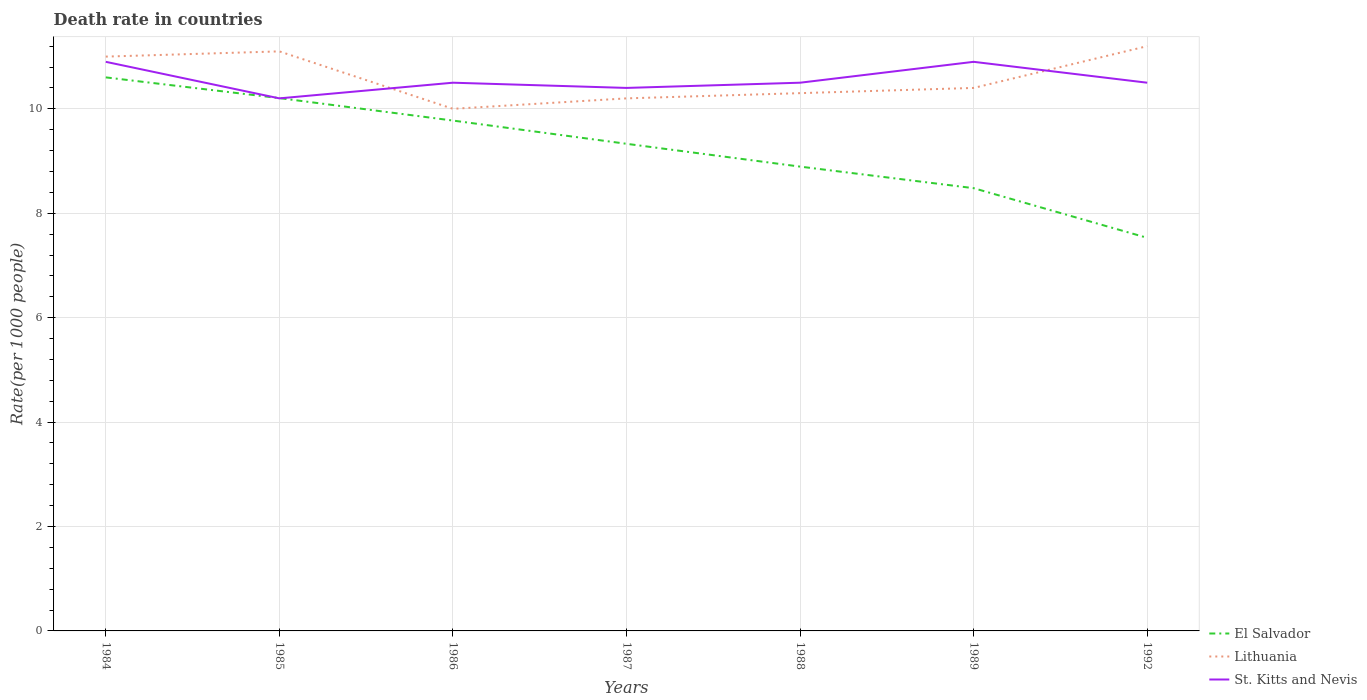Does the line corresponding to St. Kitts and Nevis intersect with the line corresponding to Lithuania?
Offer a very short reply. Yes. Across all years, what is the maximum death rate in Lithuania?
Your response must be concise. 10. What is the total death rate in Lithuania in the graph?
Give a very brief answer. -0.3. What is the difference between the highest and the second highest death rate in Lithuania?
Offer a terse response. 1.2. Is the death rate in El Salvador strictly greater than the death rate in Lithuania over the years?
Your response must be concise. Yes. How many lines are there?
Your response must be concise. 3. What is the difference between two consecutive major ticks on the Y-axis?
Provide a succinct answer. 2. Does the graph contain any zero values?
Make the answer very short. No. How are the legend labels stacked?
Give a very brief answer. Vertical. What is the title of the graph?
Make the answer very short. Death rate in countries. What is the label or title of the X-axis?
Ensure brevity in your answer.  Years. What is the label or title of the Y-axis?
Provide a succinct answer. Rate(per 1000 people). What is the Rate(per 1000 people) in El Salvador in 1984?
Your response must be concise. 10.6. What is the Rate(per 1000 people) in El Salvador in 1985?
Your answer should be very brief. 10.21. What is the Rate(per 1000 people) in Lithuania in 1985?
Ensure brevity in your answer.  11.1. What is the Rate(per 1000 people) of St. Kitts and Nevis in 1985?
Your answer should be compact. 10.2. What is the Rate(per 1000 people) in El Salvador in 1986?
Offer a terse response. 9.78. What is the Rate(per 1000 people) of St. Kitts and Nevis in 1986?
Offer a very short reply. 10.5. What is the Rate(per 1000 people) of El Salvador in 1987?
Ensure brevity in your answer.  9.33. What is the Rate(per 1000 people) in Lithuania in 1987?
Provide a short and direct response. 10.2. What is the Rate(per 1000 people) of St. Kitts and Nevis in 1987?
Your answer should be very brief. 10.4. What is the Rate(per 1000 people) in El Salvador in 1988?
Offer a very short reply. 8.89. What is the Rate(per 1000 people) of Lithuania in 1988?
Give a very brief answer. 10.3. What is the Rate(per 1000 people) in El Salvador in 1989?
Your response must be concise. 8.48. What is the Rate(per 1000 people) in El Salvador in 1992?
Offer a very short reply. 7.53. What is the Rate(per 1000 people) of Lithuania in 1992?
Offer a terse response. 11.2. What is the Rate(per 1000 people) in St. Kitts and Nevis in 1992?
Your answer should be very brief. 10.5. Across all years, what is the maximum Rate(per 1000 people) of El Salvador?
Make the answer very short. 10.6. Across all years, what is the maximum Rate(per 1000 people) in Lithuania?
Your response must be concise. 11.2. Across all years, what is the maximum Rate(per 1000 people) in St. Kitts and Nevis?
Keep it short and to the point. 10.9. Across all years, what is the minimum Rate(per 1000 people) of El Salvador?
Make the answer very short. 7.53. Across all years, what is the minimum Rate(per 1000 people) of St. Kitts and Nevis?
Give a very brief answer. 10.2. What is the total Rate(per 1000 people) in El Salvador in the graph?
Ensure brevity in your answer.  64.81. What is the total Rate(per 1000 people) in Lithuania in the graph?
Your answer should be very brief. 74.2. What is the total Rate(per 1000 people) of St. Kitts and Nevis in the graph?
Provide a short and direct response. 73.9. What is the difference between the Rate(per 1000 people) of El Salvador in 1984 and that in 1985?
Make the answer very short. 0.4. What is the difference between the Rate(per 1000 people) of St. Kitts and Nevis in 1984 and that in 1985?
Offer a very short reply. 0.7. What is the difference between the Rate(per 1000 people) in El Salvador in 1984 and that in 1986?
Provide a short and direct response. 0.83. What is the difference between the Rate(per 1000 people) of St. Kitts and Nevis in 1984 and that in 1986?
Provide a succinct answer. 0.4. What is the difference between the Rate(per 1000 people) of El Salvador in 1984 and that in 1987?
Provide a succinct answer. 1.27. What is the difference between the Rate(per 1000 people) of El Salvador in 1984 and that in 1988?
Your response must be concise. 1.71. What is the difference between the Rate(per 1000 people) of St. Kitts and Nevis in 1984 and that in 1988?
Make the answer very short. 0.4. What is the difference between the Rate(per 1000 people) of El Salvador in 1984 and that in 1989?
Provide a short and direct response. 2.12. What is the difference between the Rate(per 1000 people) of Lithuania in 1984 and that in 1989?
Offer a terse response. 0.6. What is the difference between the Rate(per 1000 people) in St. Kitts and Nevis in 1984 and that in 1989?
Your response must be concise. 0. What is the difference between the Rate(per 1000 people) of El Salvador in 1984 and that in 1992?
Offer a very short reply. 3.07. What is the difference between the Rate(per 1000 people) of St. Kitts and Nevis in 1984 and that in 1992?
Provide a short and direct response. 0.4. What is the difference between the Rate(per 1000 people) in El Salvador in 1985 and that in 1986?
Keep it short and to the point. 0.43. What is the difference between the Rate(per 1000 people) of Lithuania in 1985 and that in 1986?
Your answer should be very brief. 1.1. What is the difference between the Rate(per 1000 people) of El Salvador in 1985 and that in 1987?
Ensure brevity in your answer.  0.88. What is the difference between the Rate(per 1000 people) in St. Kitts and Nevis in 1985 and that in 1987?
Your response must be concise. -0.2. What is the difference between the Rate(per 1000 people) in El Salvador in 1985 and that in 1988?
Your answer should be compact. 1.31. What is the difference between the Rate(per 1000 people) in St. Kitts and Nevis in 1985 and that in 1988?
Ensure brevity in your answer.  -0.3. What is the difference between the Rate(per 1000 people) of El Salvador in 1985 and that in 1989?
Give a very brief answer. 1.73. What is the difference between the Rate(per 1000 people) in Lithuania in 1985 and that in 1989?
Provide a short and direct response. 0.7. What is the difference between the Rate(per 1000 people) in St. Kitts and Nevis in 1985 and that in 1989?
Offer a terse response. -0.7. What is the difference between the Rate(per 1000 people) in El Salvador in 1985 and that in 1992?
Make the answer very short. 2.68. What is the difference between the Rate(per 1000 people) of St. Kitts and Nevis in 1985 and that in 1992?
Offer a terse response. -0.3. What is the difference between the Rate(per 1000 people) in El Salvador in 1986 and that in 1987?
Provide a succinct answer. 0.45. What is the difference between the Rate(per 1000 people) in Lithuania in 1986 and that in 1987?
Keep it short and to the point. -0.2. What is the difference between the Rate(per 1000 people) of El Salvador in 1986 and that in 1988?
Give a very brief answer. 0.88. What is the difference between the Rate(per 1000 people) in El Salvador in 1986 and that in 1989?
Ensure brevity in your answer.  1.29. What is the difference between the Rate(per 1000 people) of St. Kitts and Nevis in 1986 and that in 1989?
Offer a very short reply. -0.4. What is the difference between the Rate(per 1000 people) in El Salvador in 1986 and that in 1992?
Provide a succinct answer. 2.25. What is the difference between the Rate(per 1000 people) in El Salvador in 1987 and that in 1988?
Your response must be concise. 0.44. What is the difference between the Rate(per 1000 people) in Lithuania in 1987 and that in 1988?
Your answer should be compact. -0.1. What is the difference between the Rate(per 1000 people) of St. Kitts and Nevis in 1987 and that in 1988?
Your answer should be compact. -0.1. What is the difference between the Rate(per 1000 people) of El Salvador in 1987 and that in 1989?
Provide a succinct answer. 0.85. What is the difference between the Rate(per 1000 people) in St. Kitts and Nevis in 1987 and that in 1989?
Give a very brief answer. -0.5. What is the difference between the Rate(per 1000 people) in El Salvador in 1987 and that in 1992?
Offer a terse response. 1.8. What is the difference between the Rate(per 1000 people) in Lithuania in 1987 and that in 1992?
Your answer should be very brief. -1. What is the difference between the Rate(per 1000 people) of St. Kitts and Nevis in 1987 and that in 1992?
Ensure brevity in your answer.  -0.1. What is the difference between the Rate(per 1000 people) of El Salvador in 1988 and that in 1989?
Your response must be concise. 0.41. What is the difference between the Rate(per 1000 people) in Lithuania in 1988 and that in 1989?
Provide a short and direct response. -0.1. What is the difference between the Rate(per 1000 people) of El Salvador in 1988 and that in 1992?
Provide a succinct answer. 1.36. What is the difference between the Rate(per 1000 people) in Lithuania in 1988 and that in 1992?
Make the answer very short. -0.9. What is the difference between the Rate(per 1000 people) of El Salvador in 1989 and that in 1992?
Ensure brevity in your answer.  0.95. What is the difference between the Rate(per 1000 people) of St. Kitts and Nevis in 1989 and that in 1992?
Offer a terse response. 0.4. What is the difference between the Rate(per 1000 people) of El Salvador in 1984 and the Rate(per 1000 people) of Lithuania in 1985?
Ensure brevity in your answer.  -0.5. What is the difference between the Rate(per 1000 people) of El Salvador in 1984 and the Rate(per 1000 people) of St. Kitts and Nevis in 1985?
Provide a succinct answer. 0.4. What is the difference between the Rate(per 1000 people) in Lithuania in 1984 and the Rate(per 1000 people) in St. Kitts and Nevis in 1985?
Keep it short and to the point. 0.8. What is the difference between the Rate(per 1000 people) of El Salvador in 1984 and the Rate(per 1000 people) of Lithuania in 1986?
Your answer should be very brief. 0.6. What is the difference between the Rate(per 1000 people) in El Salvador in 1984 and the Rate(per 1000 people) in St. Kitts and Nevis in 1986?
Make the answer very short. 0.1. What is the difference between the Rate(per 1000 people) in Lithuania in 1984 and the Rate(per 1000 people) in St. Kitts and Nevis in 1986?
Offer a terse response. 0.5. What is the difference between the Rate(per 1000 people) of El Salvador in 1984 and the Rate(per 1000 people) of Lithuania in 1987?
Your response must be concise. 0.4. What is the difference between the Rate(per 1000 people) of El Salvador in 1984 and the Rate(per 1000 people) of St. Kitts and Nevis in 1987?
Give a very brief answer. 0.2. What is the difference between the Rate(per 1000 people) of Lithuania in 1984 and the Rate(per 1000 people) of St. Kitts and Nevis in 1987?
Provide a short and direct response. 0.6. What is the difference between the Rate(per 1000 people) of El Salvador in 1984 and the Rate(per 1000 people) of Lithuania in 1988?
Ensure brevity in your answer.  0.3. What is the difference between the Rate(per 1000 people) of El Salvador in 1984 and the Rate(per 1000 people) of St. Kitts and Nevis in 1988?
Your response must be concise. 0.1. What is the difference between the Rate(per 1000 people) in El Salvador in 1984 and the Rate(per 1000 people) in Lithuania in 1989?
Make the answer very short. 0.2. What is the difference between the Rate(per 1000 people) in El Salvador in 1984 and the Rate(per 1000 people) in St. Kitts and Nevis in 1989?
Offer a terse response. -0.3. What is the difference between the Rate(per 1000 people) of El Salvador in 1984 and the Rate(per 1000 people) of Lithuania in 1992?
Offer a very short reply. -0.6. What is the difference between the Rate(per 1000 people) in El Salvador in 1984 and the Rate(per 1000 people) in St. Kitts and Nevis in 1992?
Provide a short and direct response. 0.1. What is the difference between the Rate(per 1000 people) in El Salvador in 1985 and the Rate(per 1000 people) in Lithuania in 1986?
Your answer should be compact. 0.2. What is the difference between the Rate(per 1000 people) of El Salvador in 1985 and the Rate(per 1000 people) of St. Kitts and Nevis in 1986?
Provide a succinct answer. -0.29. What is the difference between the Rate(per 1000 people) of El Salvador in 1985 and the Rate(per 1000 people) of Lithuania in 1987?
Keep it short and to the point. 0.01. What is the difference between the Rate(per 1000 people) of El Salvador in 1985 and the Rate(per 1000 people) of St. Kitts and Nevis in 1987?
Provide a short and direct response. -0.2. What is the difference between the Rate(per 1000 people) of Lithuania in 1985 and the Rate(per 1000 people) of St. Kitts and Nevis in 1987?
Your response must be concise. 0.7. What is the difference between the Rate(per 1000 people) in El Salvador in 1985 and the Rate(per 1000 people) in Lithuania in 1988?
Your answer should be very brief. -0.1. What is the difference between the Rate(per 1000 people) of El Salvador in 1985 and the Rate(per 1000 people) of St. Kitts and Nevis in 1988?
Offer a very short reply. -0.29. What is the difference between the Rate(per 1000 people) of El Salvador in 1985 and the Rate(per 1000 people) of Lithuania in 1989?
Ensure brevity in your answer.  -0.2. What is the difference between the Rate(per 1000 people) of El Salvador in 1985 and the Rate(per 1000 people) of St. Kitts and Nevis in 1989?
Ensure brevity in your answer.  -0.69. What is the difference between the Rate(per 1000 people) of El Salvador in 1985 and the Rate(per 1000 people) of Lithuania in 1992?
Give a very brief answer. -0.99. What is the difference between the Rate(per 1000 people) in El Salvador in 1985 and the Rate(per 1000 people) in St. Kitts and Nevis in 1992?
Offer a very short reply. -0.29. What is the difference between the Rate(per 1000 people) of El Salvador in 1986 and the Rate(per 1000 people) of Lithuania in 1987?
Make the answer very short. -0.42. What is the difference between the Rate(per 1000 people) of El Salvador in 1986 and the Rate(per 1000 people) of St. Kitts and Nevis in 1987?
Give a very brief answer. -0.62. What is the difference between the Rate(per 1000 people) of El Salvador in 1986 and the Rate(per 1000 people) of Lithuania in 1988?
Give a very brief answer. -0.53. What is the difference between the Rate(per 1000 people) in El Salvador in 1986 and the Rate(per 1000 people) in St. Kitts and Nevis in 1988?
Your answer should be compact. -0.72. What is the difference between the Rate(per 1000 people) in Lithuania in 1986 and the Rate(per 1000 people) in St. Kitts and Nevis in 1988?
Give a very brief answer. -0.5. What is the difference between the Rate(per 1000 people) in El Salvador in 1986 and the Rate(per 1000 people) in Lithuania in 1989?
Your answer should be very brief. -0.62. What is the difference between the Rate(per 1000 people) in El Salvador in 1986 and the Rate(per 1000 people) in St. Kitts and Nevis in 1989?
Offer a very short reply. -1.12. What is the difference between the Rate(per 1000 people) in El Salvador in 1986 and the Rate(per 1000 people) in Lithuania in 1992?
Make the answer very short. -1.43. What is the difference between the Rate(per 1000 people) of El Salvador in 1986 and the Rate(per 1000 people) of St. Kitts and Nevis in 1992?
Keep it short and to the point. -0.72. What is the difference between the Rate(per 1000 people) of El Salvador in 1987 and the Rate(per 1000 people) of Lithuania in 1988?
Give a very brief answer. -0.97. What is the difference between the Rate(per 1000 people) in El Salvador in 1987 and the Rate(per 1000 people) in St. Kitts and Nevis in 1988?
Your answer should be very brief. -1.17. What is the difference between the Rate(per 1000 people) in Lithuania in 1987 and the Rate(per 1000 people) in St. Kitts and Nevis in 1988?
Offer a terse response. -0.3. What is the difference between the Rate(per 1000 people) of El Salvador in 1987 and the Rate(per 1000 people) of Lithuania in 1989?
Offer a terse response. -1.07. What is the difference between the Rate(per 1000 people) of El Salvador in 1987 and the Rate(per 1000 people) of St. Kitts and Nevis in 1989?
Offer a terse response. -1.57. What is the difference between the Rate(per 1000 people) in Lithuania in 1987 and the Rate(per 1000 people) in St. Kitts and Nevis in 1989?
Make the answer very short. -0.7. What is the difference between the Rate(per 1000 people) of El Salvador in 1987 and the Rate(per 1000 people) of Lithuania in 1992?
Offer a very short reply. -1.87. What is the difference between the Rate(per 1000 people) in El Salvador in 1987 and the Rate(per 1000 people) in St. Kitts and Nevis in 1992?
Make the answer very short. -1.17. What is the difference between the Rate(per 1000 people) in Lithuania in 1987 and the Rate(per 1000 people) in St. Kitts and Nevis in 1992?
Provide a succinct answer. -0.3. What is the difference between the Rate(per 1000 people) of El Salvador in 1988 and the Rate(per 1000 people) of Lithuania in 1989?
Give a very brief answer. -1.51. What is the difference between the Rate(per 1000 people) of El Salvador in 1988 and the Rate(per 1000 people) of St. Kitts and Nevis in 1989?
Your answer should be compact. -2.01. What is the difference between the Rate(per 1000 people) in El Salvador in 1988 and the Rate(per 1000 people) in Lithuania in 1992?
Keep it short and to the point. -2.31. What is the difference between the Rate(per 1000 people) of El Salvador in 1988 and the Rate(per 1000 people) of St. Kitts and Nevis in 1992?
Your answer should be compact. -1.61. What is the difference between the Rate(per 1000 people) in El Salvador in 1989 and the Rate(per 1000 people) in Lithuania in 1992?
Your response must be concise. -2.72. What is the difference between the Rate(per 1000 people) in El Salvador in 1989 and the Rate(per 1000 people) in St. Kitts and Nevis in 1992?
Provide a succinct answer. -2.02. What is the average Rate(per 1000 people) of El Salvador per year?
Make the answer very short. 9.26. What is the average Rate(per 1000 people) in St. Kitts and Nevis per year?
Ensure brevity in your answer.  10.56. In the year 1984, what is the difference between the Rate(per 1000 people) in El Salvador and Rate(per 1000 people) in Lithuania?
Make the answer very short. -0.4. In the year 1984, what is the difference between the Rate(per 1000 people) in El Salvador and Rate(per 1000 people) in St. Kitts and Nevis?
Make the answer very short. -0.3. In the year 1985, what is the difference between the Rate(per 1000 people) of El Salvador and Rate(per 1000 people) of Lithuania?
Your answer should be very brief. -0.9. In the year 1985, what is the difference between the Rate(per 1000 people) of El Salvador and Rate(per 1000 people) of St. Kitts and Nevis?
Keep it short and to the point. 0.01. In the year 1985, what is the difference between the Rate(per 1000 people) in Lithuania and Rate(per 1000 people) in St. Kitts and Nevis?
Your answer should be compact. 0.9. In the year 1986, what is the difference between the Rate(per 1000 people) of El Salvador and Rate(per 1000 people) of Lithuania?
Provide a succinct answer. -0.23. In the year 1986, what is the difference between the Rate(per 1000 people) in El Salvador and Rate(per 1000 people) in St. Kitts and Nevis?
Offer a terse response. -0.72. In the year 1986, what is the difference between the Rate(per 1000 people) in Lithuania and Rate(per 1000 people) in St. Kitts and Nevis?
Provide a succinct answer. -0.5. In the year 1987, what is the difference between the Rate(per 1000 people) in El Salvador and Rate(per 1000 people) in Lithuania?
Offer a very short reply. -0.87. In the year 1987, what is the difference between the Rate(per 1000 people) of El Salvador and Rate(per 1000 people) of St. Kitts and Nevis?
Make the answer very short. -1.07. In the year 1988, what is the difference between the Rate(per 1000 people) in El Salvador and Rate(per 1000 people) in Lithuania?
Ensure brevity in your answer.  -1.41. In the year 1988, what is the difference between the Rate(per 1000 people) of El Salvador and Rate(per 1000 people) of St. Kitts and Nevis?
Your answer should be compact. -1.61. In the year 1989, what is the difference between the Rate(per 1000 people) of El Salvador and Rate(per 1000 people) of Lithuania?
Make the answer very short. -1.92. In the year 1989, what is the difference between the Rate(per 1000 people) in El Salvador and Rate(per 1000 people) in St. Kitts and Nevis?
Provide a succinct answer. -2.42. In the year 1992, what is the difference between the Rate(per 1000 people) of El Salvador and Rate(per 1000 people) of Lithuania?
Make the answer very short. -3.67. In the year 1992, what is the difference between the Rate(per 1000 people) of El Salvador and Rate(per 1000 people) of St. Kitts and Nevis?
Ensure brevity in your answer.  -2.97. What is the ratio of the Rate(per 1000 people) in El Salvador in 1984 to that in 1985?
Provide a succinct answer. 1.04. What is the ratio of the Rate(per 1000 people) in Lithuania in 1984 to that in 1985?
Give a very brief answer. 0.99. What is the ratio of the Rate(per 1000 people) of St. Kitts and Nevis in 1984 to that in 1985?
Provide a succinct answer. 1.07. What is the ratio of the Rate(per 1000 people) of El Salvador in 1984 to that in 1986?
Offer a very short reply. 1.08. What is the ratio of the Rate(per 1000 people) in St. Kitts and Nevis in 1984 to that in 1986?
Offer a terse response. 1.04. What is the ratio of the Rate(per 1000 people) of El Salvador in 1984 to that in 1987?
Your response must be concise. 1.14. What is the ratio of the Rate(per 1000 people) of Lithuania in 1984 to that in 1987?
Your answer should be compact. 1.08. What is the ratio of the Rate(per 1000 people) in St. Kitts and Nevis in 1984 to that in 1987?
Provide a succinct answer. 1.05. What is the ratio of the Rate(per 1000 people) of El Salvador in 1984 to that in 1988?
Keep it short and to the point. 1.19. What is the ratio of the Rate(per 1000 people) in Lithuania in 1984 to that in 1988?
Offer a terse response. 1.07. What is the ratio of the Rate(per 1000 people) in St. Kitts and Nevis in 1984 to that in 1988?
Offer a terse response. 1.04. What is the ratio of the Rate(per 1000 people) in El Salvador in 1984 to that in 1989?
Your response must be concise. 1.25. What is the ratio of the Rate(per 1000 people) in Lithuania in 1984 to that in 1989?
Ensure brevity in your answer.  1.06. What is the ratio of the Rate(per 1000 people) in El Salvador in 1984 to that in 1992?
Keep it short and to the point. 1.41. What is the ratio of the Rate(per 1000 people) of Lithuania in 1984 to that in 1992?
Make the answer very short. 0.98. What is the ratio of the Rate(per 1000 people) of St. Kitts and Nevis in 1984 to that in 1992?
Offer a very short reply. 1.04. What is the ratio of the Rate(per 1000 people) in El Salvador in 1985 to that in 1986?
Your answer should be compact. 1.04. What is the ratio of the Rate(per 1000 people) in Lithuania in 1985 to that in 1986?
Offer a terse response. 1.11. What is the ratio of the Rate(per 1000 people) in St. Kitts and Nevis in 1985 to that in 1986?
Your answer should be very brief. 0.97. What is the ratio of the Rate(per 1000 people) in El Salvador in 1985 to that in 1987?
Make the answer very short. 1.09. What is the ratio of the Rate(per 1000 people) of Lithuania in 1985 to that in 1987?
Offer a very short reply. 1.09. What is the ratio of the Rate(per 1000 people) of St. Kitts and Nevis in 1985 to that in 1987?
Give a very brief answer. 0.98. What is the ratio of the Rate(per 1000 people) of El Salvador in 1985 to that in 1988?
Give a very brief answer. 1.15. What is the ratio of the Rate(per 1000 people) of Lithuania in 1985 to that in 1988?
Offer a terse response. 1.08. What is the ratio of the Rate(per 1000 people) in St. Kitts and Nevis in 1985 to that in 1988?
Your response must be concise. 0.97. What is the ratio of the Rate(per 1000 people) in El Salvador in 1985 to that in 1989?
Your answer should be very brief. 1.2. What is the ratio of the Rate(per 1000 people) of Lithuania in 1985 to that in 1989?
Provide a succinct answer. 1.07. What is the ratio of the Rate(per 1000 people) in St. Kitts and Nevis in 1985 to that in 1989?
Keep it short and to the point. 0.94. What is the ratio of the Rate(per 1000 people) of El Salvador in 1985 to that in 1992?
Make the answer very short. 1.36. What is the ratio of the Rate(per 1000 people) of Lithuania in 1985 to that in 1992?
Your answer should be compact. 0.99. What is the ratio of the Rate(per 1000 people) in St. Kitts and Nevis in 1985 to that in 1992?
Keep it short and to the point. 0.97. What is the ratio of the Rate(per 1000 people) of El Salvador in 1986 to that in 1987?
Your answer should be very brief. 1.05. What is the ratio of the Rate(per 1000 people) in Lithuania in 1986 to that in 1987?
Your answer should be very brief. 0.98. What is the ratio of the Rate(per 1000 people) of St. Kitts and Nevis in 1986 to that in 1987?
Your answer should be very brief. 1.01. What is the ratio of the Rate(per 1000 people) of El Salvador in 1986 to that in 1988?
Your response must be concise. 1.1. What is the ratio of the Rate(per 1000 people) in Lithuania in 1986 to that in 1988?
Give a very brief answer. 0.97. What is the ratio of the Rate(per 1000 people) of El Salvador in 1986 to that in 1989?
Keep it short and to the point. 1.15. What is the ratio of the Rate(per 1000 people) of Lithuania in 1986 to that in 1989?
Make the answer very short. 0.96. What is the ratio of the Rate(per 1000 people) in St. Kitts and Nevis in 1986 to that in 1989?
Offer a terse response. 0.96. What is the ratio of the Rate(per 1000 people) in El Salvador in 1986 to that in 1992?
Your answer should be compact. 1.3. What is the ratio of the Rate(per 1000 people) of Lithuania in 1986 to that in 1992?
Offer a very short reply. 0.89. What is the ratio of the Rate(per 1000 people) in El Salvador in 1987 to that in 1988?
Your answer should be compact. 1.05. What is the ratio of the Rate(per 1000 people) in Lithuania in 1987 to that in 1988?
Provide a succinct answer. 0.99. What is the ratio of the Rate(per 1000 people) in St. Kitts and Nevis in 1987 to that in 1988?
Keep it short and to the point. 0.99. What is the ratio of the Rate(per 1000 people) of El Salvador in 1987 to that in 1989?
Your answer should be compact. 1.1. What is the ratio of the Rate(per 1000 people) in Lithuania in 1987 to that in 1989?
Offer a very short reply. 0.98. What is the ratio of the Rate(per 1000 people) of St. Kitts and Nevis in 1987 to that in 1989?
Make the answer very short. 0.95. What is the ratio of the Rate(per 1000 people) of El Salvador in 1987 to that in 1992?
Offer a very short reply. 1.24. What is the ratio of the Rate(per 1000 people) of Lithuania in 1987 to that in 1992?
Your response must be concise. 0.91. What is the ratio of the Rate(per 1000 people) in St. Kitts and Nevis in 1987 to that in 1992?
Make the answer very short. 0.99. What is the ratio of the Rate(per 1000 people) of El Salvador in 1988 to that in 1989?
Offer a very short reply. 1.05. What is the ratio of the Rate(per 1000 people) in Lithuania in 1988 to that in 1989?
Give a very brief answer. 0.99. What is the ratio of the Rate(per 1000 people) of St. Kitts and Nevis in 1988 to that in 1989?
Give a very brief answer. 0.96. What is the ratio of the Rate(per 1000 people) in El Salvador in 1988 to that in 1992?
Make the answer very short. 1.18. What is the ratio of the Rate(per 1000 people) of Lithuania in 1988 to that in 1992?
Provide a succinct answer. 0.92. What is the ratio of the Rate(per 1000 people) of El Salvador in 1989 to that in 1992?
Offer a very short reply. 1.13. What is the ratio of the Rate(per 1000 people) in Lithuania in 1989 to that in 1992?
Give a very brief answer. 0.93. What is the ratio of the Rate(per 1000 people) of St. Kitts and Nevis in 1989 to that in 1992?
Make the answer very short. 1.04. What is the difference between the highest and the second highest Rate(per 1000 people) in El Salvador?
Provide a succinct answer. 0.4. What is the difference between the highest and the second highest Rate(per 1000 people) in Lithuania?
Give a very brief answer. 0.1. What is the difference between the highest and the lowest Rate(per 1000 people) in El Salvador?
Provide a short and direct response. 3.07. What is the difference between the highest and the lowest Rate(per 1000 people) in Lithuania?
Make the answer very short. 1.2. What is the difference between the highest and the lowest Rate(per 1000 people) in St. Kitts and Nevis?
Ensure brevity in your answer.  0.7. 